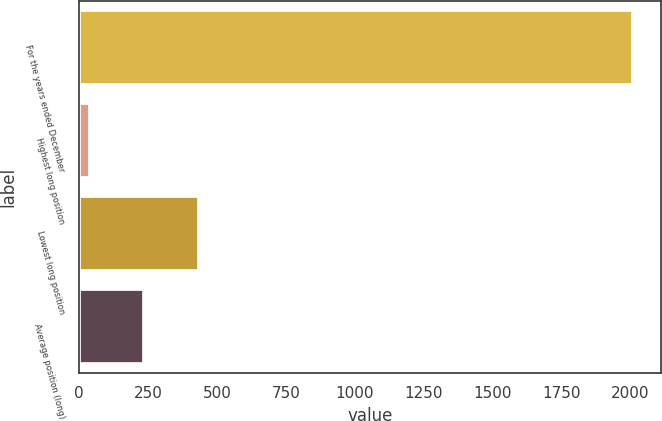Convert chart. <chart><loc_0><loc_0><loc_500><loc_500><bar_chart><fcel>For the years ended December<fcel>Highest long position<fcel>Lowest long position<fcel>Average position (long)<nl><fcel>2010<fcel>38.6<fcel>432.88<fcel>235.74<nl></chart> 